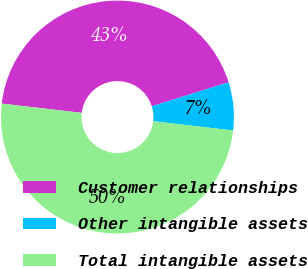Convert chart to OTSL. <chart><loc_0><loc_0><loc_500><loc_500><pie_chart><fcel>Customer relationships<fcel>Other intangible assets<fcel>Total intangible assets<nl><fcel>43.33%<fcel>6.67%<fcel>50.0%<nl></chart> 